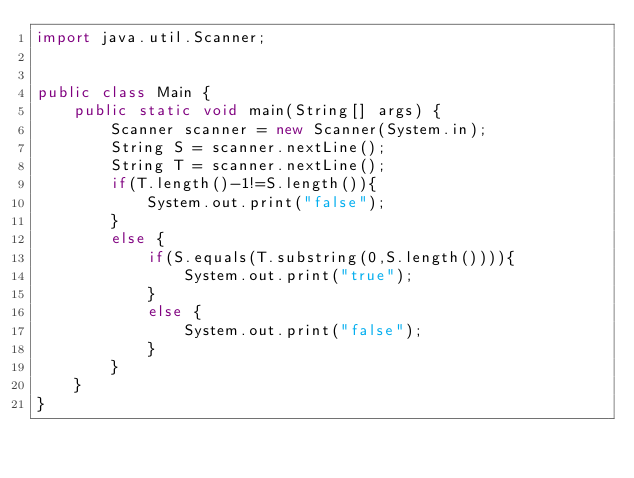<code> <loc_0><loc_0><loc_500><loc_500><_Java_>import java.util.Scanner;


public class Main {
    public static void main(String[] args) {
        Scanner scanner = new Scanner(System.in);
        String S = scanner.nextLine();
        String T = scanner.nextLine();
        if(T.length()-1!=S.length()){
            System.out.print("false");
        }
        else {
            if(S.equals(T.substring(0,S.length()))){
                System.out.print("true");
            }
            else {
                System.out.print("false");
            }
        }
    }
}
</code> 